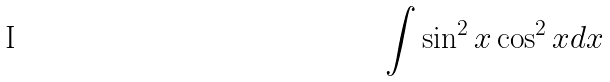Convert formula to latex. <formula><loc_0><loc_0><loc_500><loc_500>\int \sin ^ { 2 } x \cos ^ { 2 } x d x</formula> 